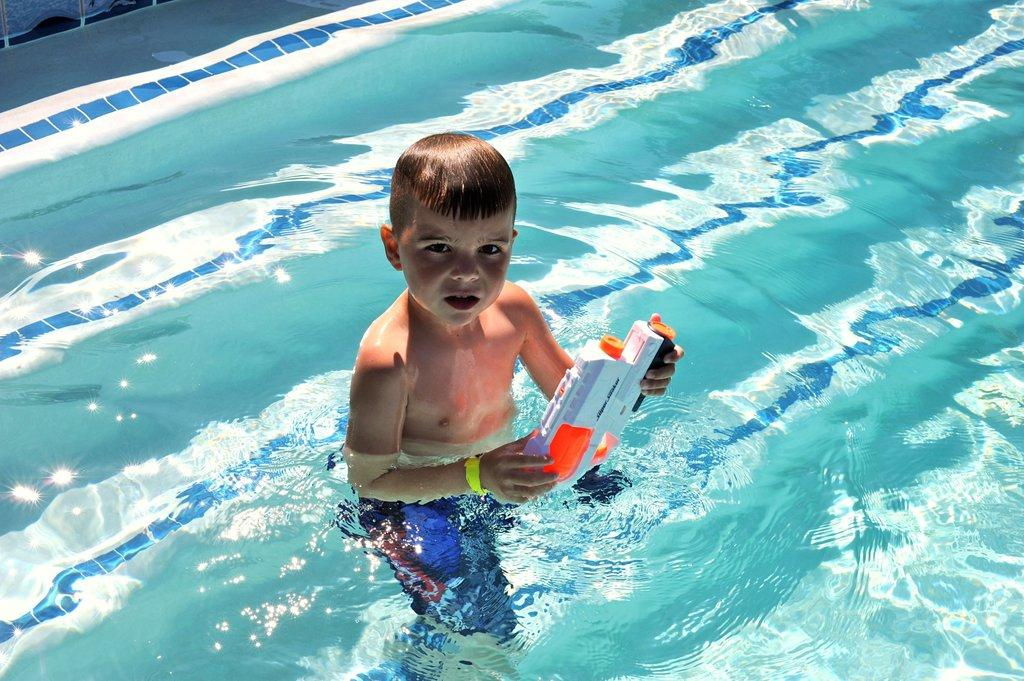What is the boy doing in the image? The boy is in the water. What is the boy holding while in the water? The boy is holding a toy. What type of paint is being used on the tub in the image? There is no tub present in the image, and therefore no paint can be observed. 